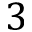Convert formula to latex. <formula><loc_0><loc_0><loc_500><loc_500>3</formula> 